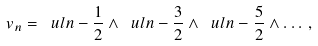Convert formula to latex. <formula><loc_0><loc_0><loc_500><loc_500>v _ { n } = \ u l { n - \frac { 1 } { 2 } } \wedge \ u l { n - \frac { 3 } { 2 } } \wedge \ u l { n - \frac { 5 } { 2 } } \wedge \dots \, ,</formula> 